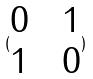<formula> <loc_0><loc_0><loc_500><loc_500>( \begin{matrix} 0 & & 1 \\ 1 & & 0 \end{matrix} )</formula> 